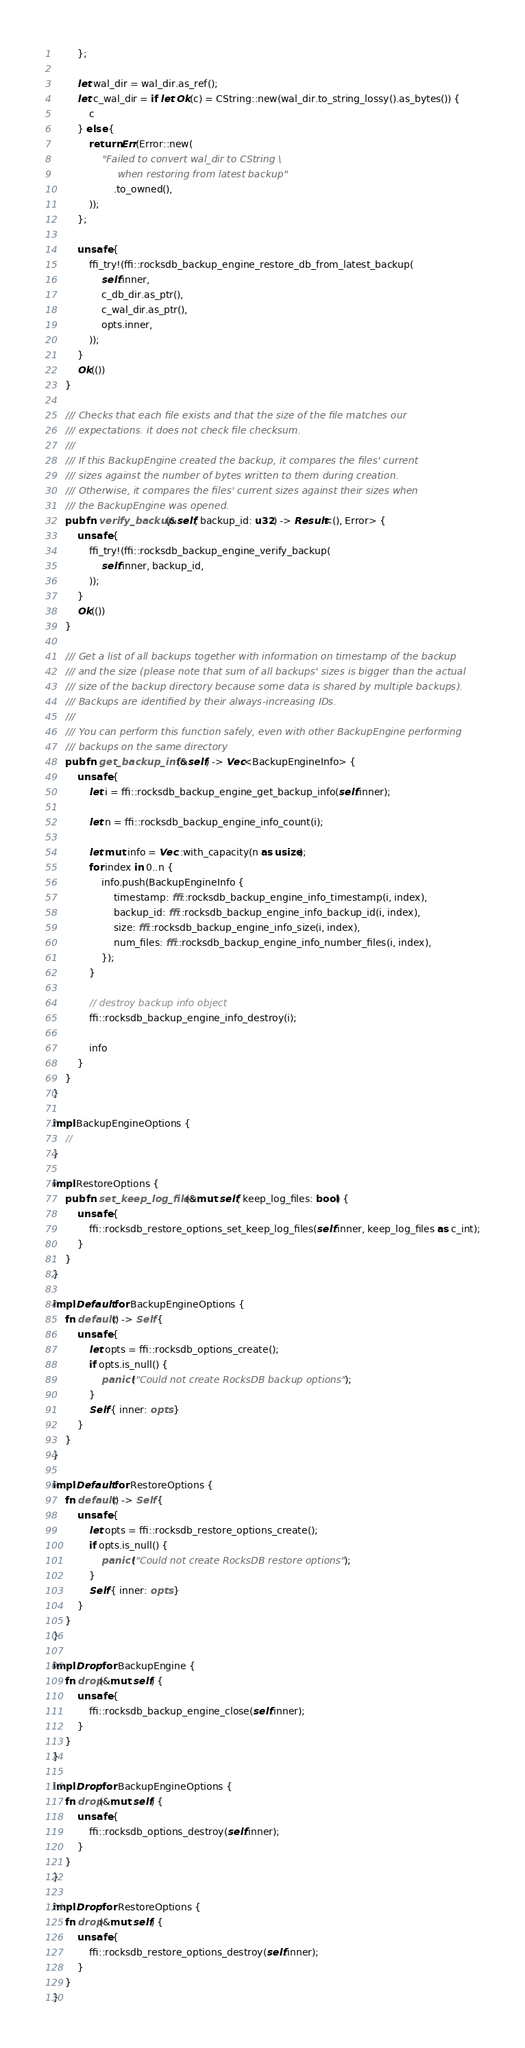Convert code to text. <code><loc_0><loc_0><loc_500><loc_500><_Rust_>        };

        let wal_dir = wal_dir.as_ref();
        let c_wal_dir = if let Ok(c) = CString::new(wal_dir.to_string_lossy().as_bytes()) {
            c
        } else {
            return Err(Error::new(
                "Failed to convert wal_dir to CString \
                     when restoring from latest backup"
                    .to_owned(),
            ));
        };

        unsafe {
            ffi_try!(ffi::rocksdb_backup_engine_restore_db_from_latest_backup(
                self.inner,
                c_db_dir.as_ptr(),
                c_wal_dir.as_ptr(),
                opts.inner,
            ));
        }
        Ok(())
    }

    /// Checks that each file exists and that the size of the file matches our
    /// expectations. it does not check file checksum.
    ///
    /// If this BackupEngine created the backup, it compares the files' current
    /// sizes against the number of bytes written to them during creation.
    /// Otherwise, it compares the files' current sizes against their sizes when
    /// the BackupEngine was opened.
    pub fn verify_backup(&self, backup_id: u32) -> Result<(), Error> {
        unsafe {
            ffi_try!(ffi::rocksdb_backup_engine_verify_backup(
                self.inner, backup_id,
            ));
        }
        Ok(())
    }

    /// Get a list of all backups together with information on timestamp of the backup
    /// and the size (please note that sum of all backups' sizes is bigger than the actual
    /// size of the backup directory because some data is shared by multiple backups).
    /// Backups are identified by their always-increasing IDs.
    ///
    /// You can perform this function safely, even with other BackupEngine performing
    /// backups on the same directory
    pub fn get_backup_info(&self) -> Vec<BackupEngineInfo> {
        unsafe {
            let i = ffi::rocksdb_backup_engine_get_backup_info(self.inner);

            let n = ffi::rocksdb_backup_engine_info_count(i);

            let mut info = Vec::with_capacity(n as usize);
            for index in 0..n {
                info.push(BackupEngineInfo {
                    timestamp: ffi::rocksdb_backup_engine_info_timestamp(i, index),
                    backup_id: ffi::rocksdb_backup_engine_info_backup_id(i, index),
                    size: ffi::rocksdb_backup_engine_info_size(i, index),
                    num_files: ffi::rocksdb_backup_engine_info_number_files(i, index),
                });
            }

            // destroy backup info object
            ffi::rocksdb_backup_engine_info_destroy(i);

            info
        }
    }
}

impl BackupEngineOptions {
    //
}

impl RestoreOptions {
    pub fn set_keep_log_files(&mut self, keep_log_files: bool) {
        unsafe {
            ffi::rocksdb_restore_options_set_keep_log_files(self.inner, keep_log_files as c_int);
        }
    }
}

impl Default for BackupEngineOptions {
    fn default() -> Self {
        unsafe {
            let opts = ffi::rocksdb_options_create();
            if opts.is_null() {
                panic!("Could not create RocksDB backup options");
            }
            Self { inner: opts }
        }
    }
}

impl Default for RestoreOptions {
    fn default() -> Self {
        unsafe {
            let opts = ffi::rocksdb_restore_options_create();
            if opts.is_null() {
                panic!("Could not create RocksDB restore options");
            }
            Self { inner: opts }
        }
    }
}

impl Drop for BackupEngine {
    fn drop(&mut self) {
        unsafe {
            ffi::rocksdb_backup_engine_close(self.inner);
        }
    }
}

impl Drop for BackupEngineOptions {
    fn drop(&mut self) {
        unsafe {
            ffi::rocksdb_options_destroy(self.inner);
        }
    }
}

impl Drop for RestoreOptions {
    fn drop(&mut self) {
        unsafe {
            ffi::rocksdb_restore_options_destroy(self.inner);
        }
    }
}
</code> 